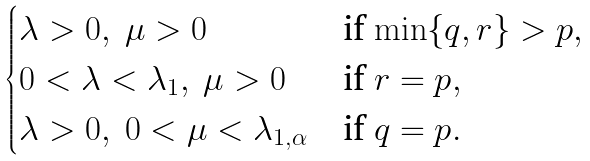<formula> <loc_0><loc_0><loc_500><loc_500>\begin{cases} \lambda > 0 , \ \mu > 0 & \text {if $\min\{q, r\}>p$} , \\ 0 < \lambda < \lambda _ { 1 } , \ \mu > 0 & \text {if $r=p$} , \\ \lambda > 0 , \ 0 < \mu < \lambda _ { 1 , \alpha } & \text {if $q=p$} . \end{cases}</formula> 